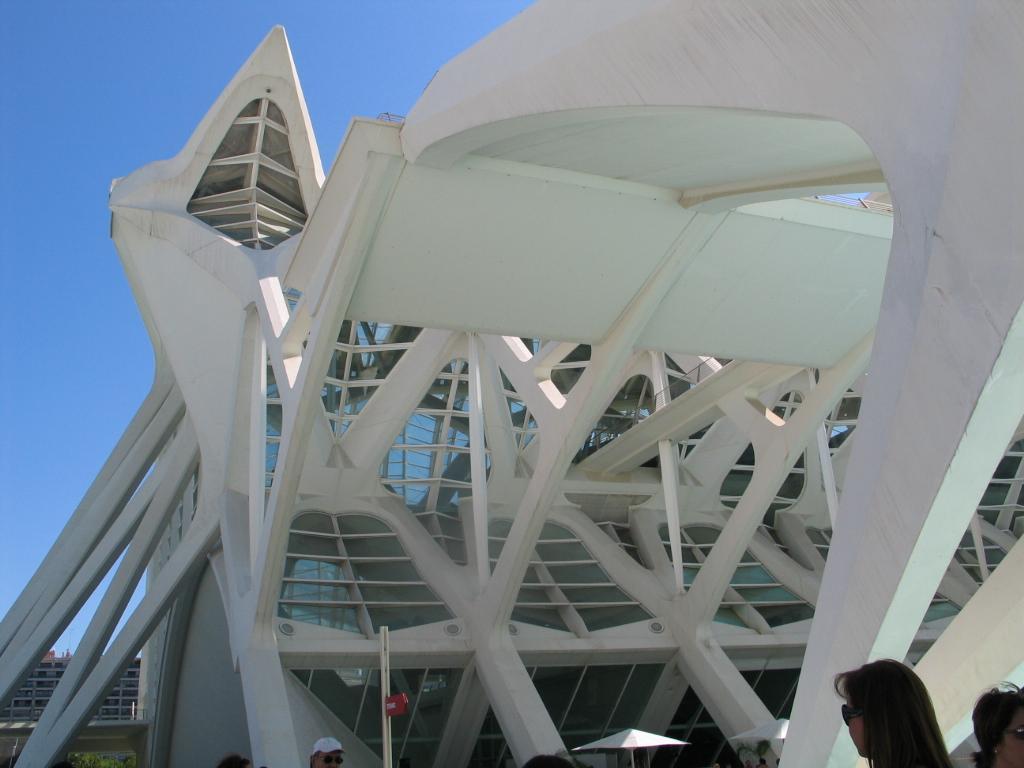Could you give a brief overview of what you see in this image? In this image we can see buildings, poles, parasols, persons and sky in the background. 